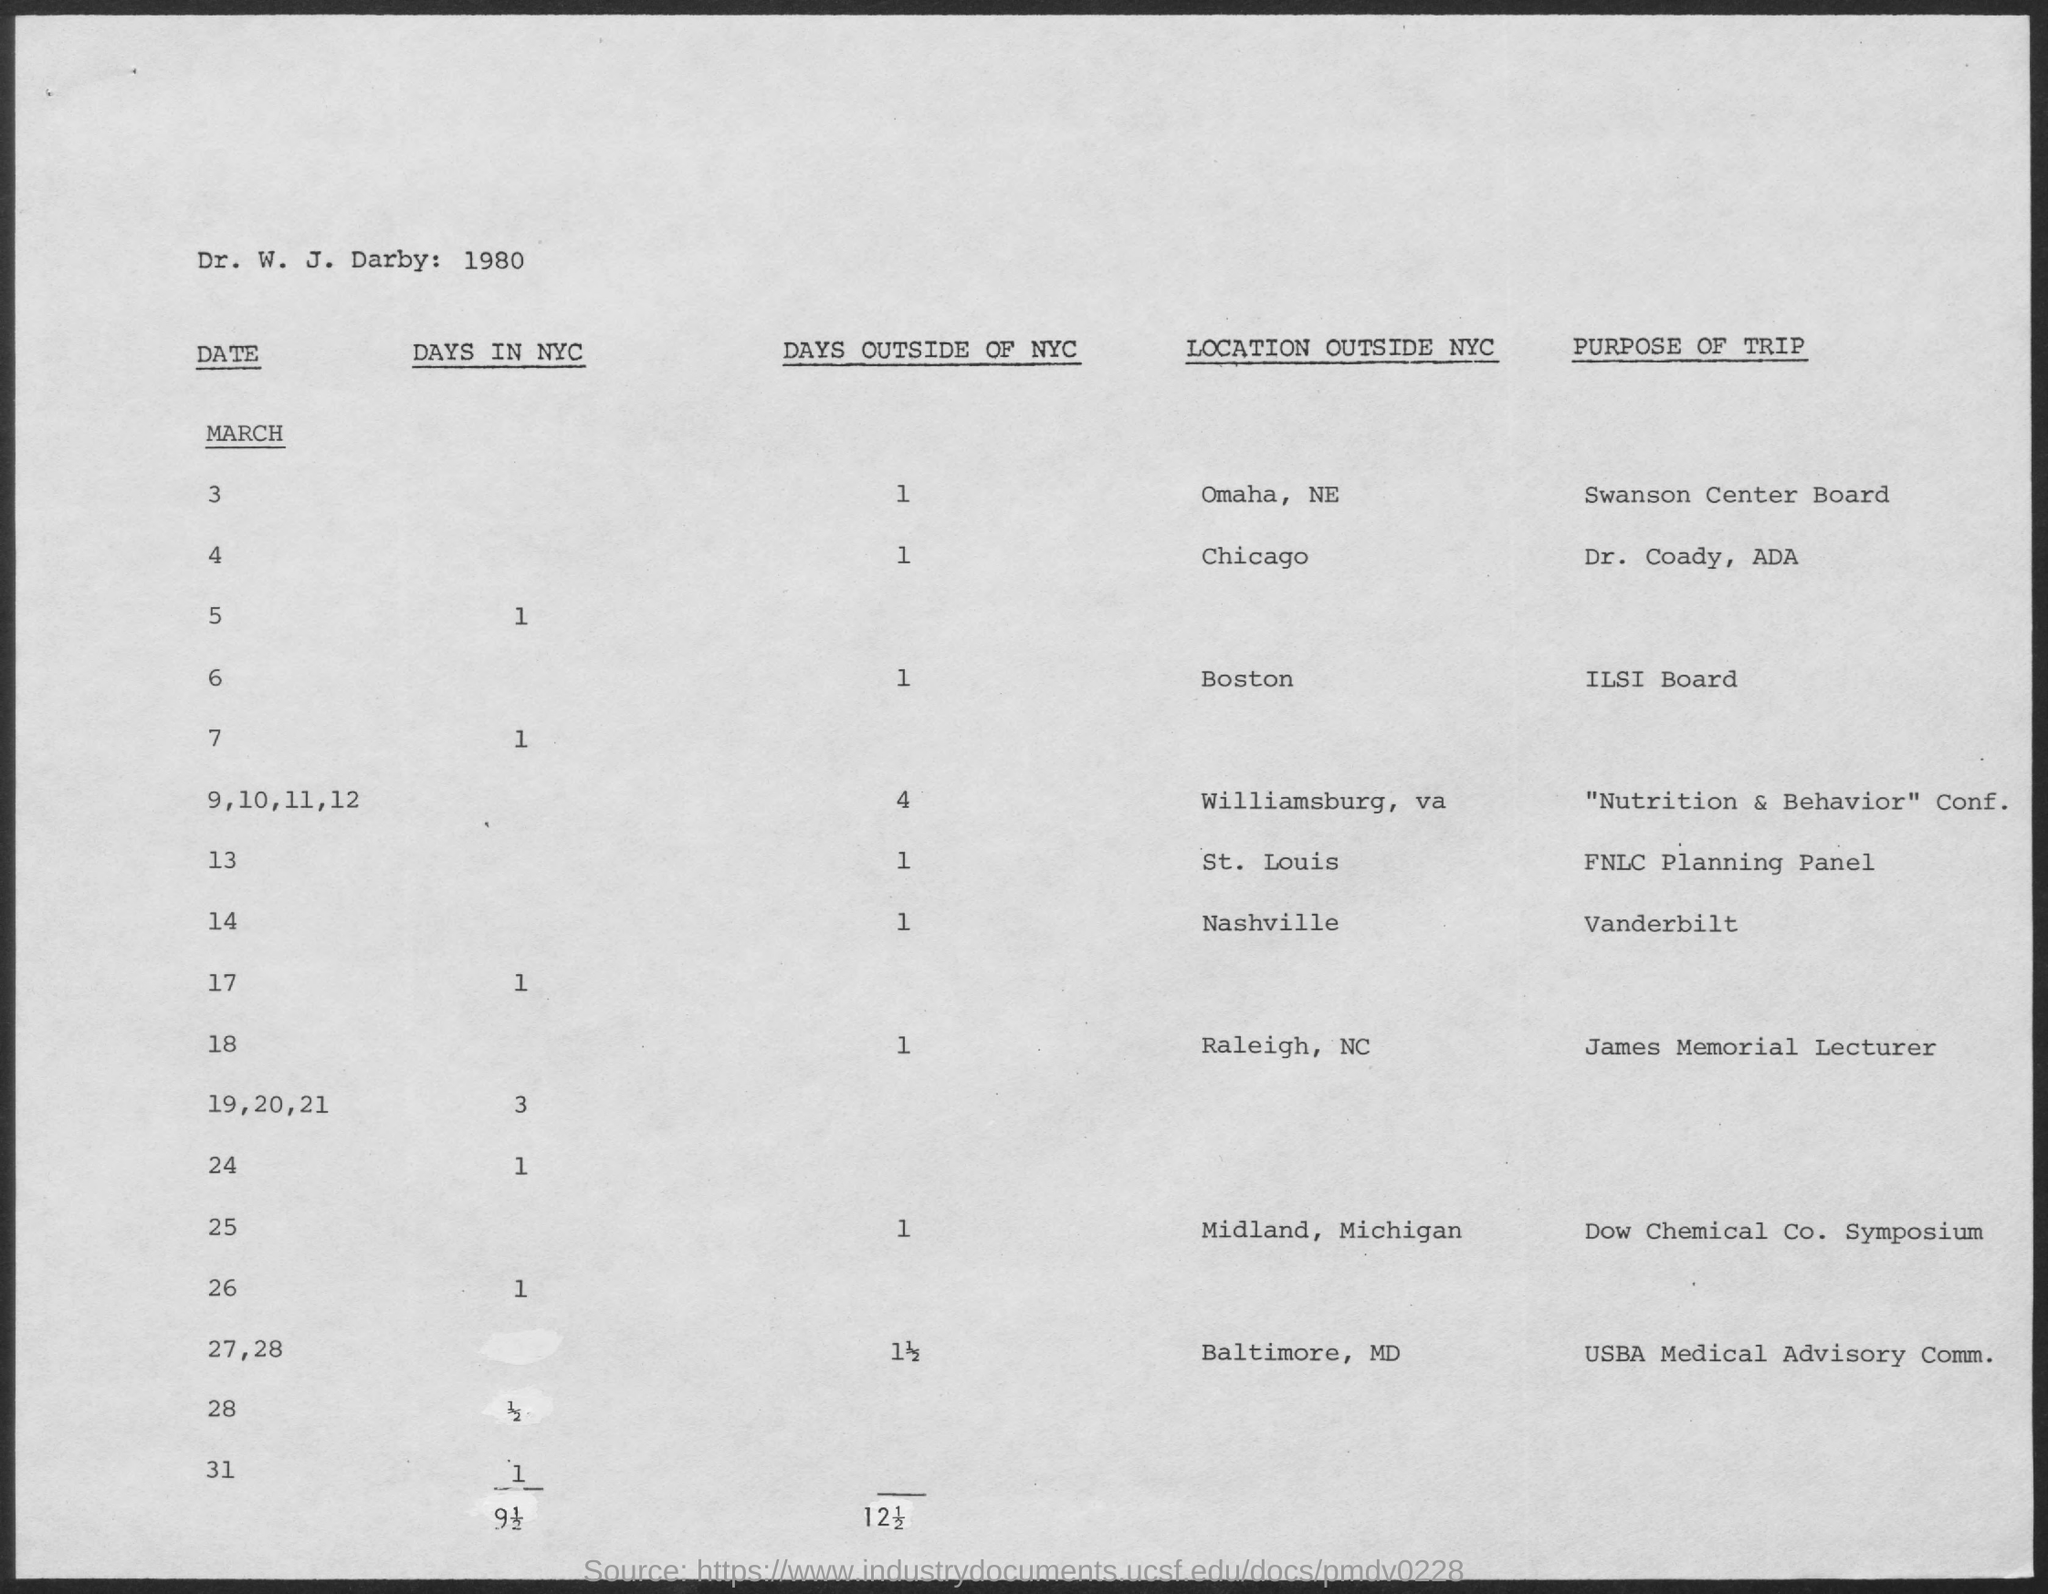Identify some key points in this picture. On March 18, the purpose of the trip is to attend the James Memorial Lecturer. 